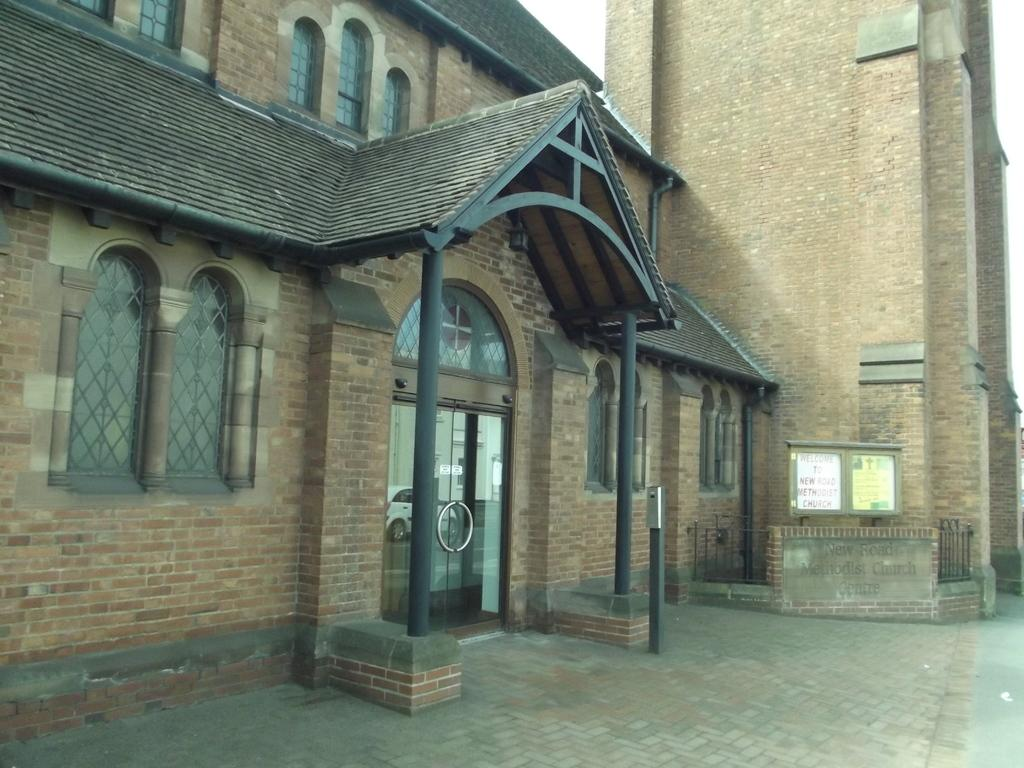What type of structure can be seen in the image? There is a house and a building in the image. Can you describe the house in the image? The facts provided do not give specific details about the house, but it is present in the image. What other type of structure is visible in the image? There is a building in the image. Where is the secretary sitting in the image? There is no secretary present in the image. What type of street can be seen in the image? The facts provided do not mention a street, so it cannot be determined if one is present in the image. 